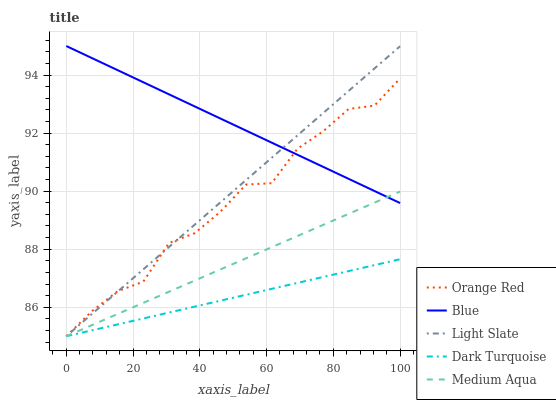Does Dark Turquoise have the minimum area under the curve?
Answer yes or no. Yes. Does Blue have the maximum area under the curve?
Answer yes or no. Yes. Does Light Slate have the minimum area under the curve?
Answer yes or no. No. Does Light Slate have the maximum area under the curve?
Answer yes or no. No. Is Medium Aqua the smoothest?
Answer yes or no. Yes. Is Orange Red the roughest?
Answer yes or no. Yes. Is Light Slate the smoothest?
Answer yes or no. No. Is Light Slate the roughest?
Answer yes or no. No. Does Light Slate have the lowest value?
Answer yes or no. Yes. Does Blue have the highest value?
Answer yes or no. Yes. Does Light Slate have the highest value?
Answer yes or no. No. Is Dark Turquoise less than Blue?
Answer yes or no. Yes. Is Blue greater than Dark Turquoise?
Answer yes or no. Yes. Does Dark Turquoise intersect Medium Aqua?
Answer yes or no. Yes. Is Dark Turquoise less than Medium Aqua?
Answer yes or no. No. Is Dark Turquoise greater than Medium Aqua?
Answer yes or no. No. Does Dark Turquoise intersect Blue?
Answer yes or no. No. 